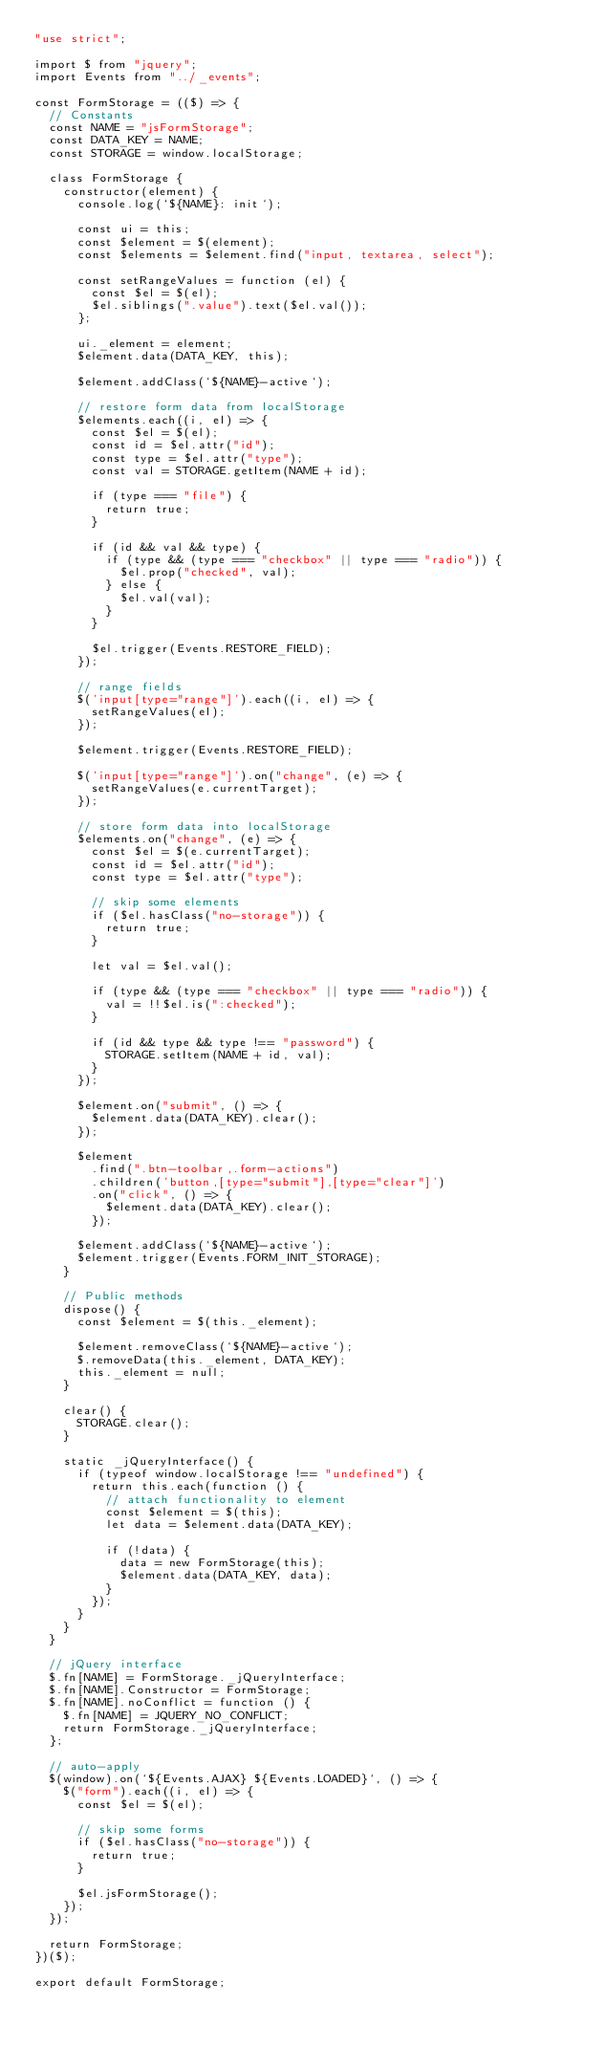Convert code to text. <code><loc_0><loc_0><loc_500><loc_500><_JavaScript_>"use strict";

import $ from "jquery";
import Events from "../_events";

const FormStorage = (($) => {
  // Constants
  const NAME = "jsFormStorage";
  const DATA_KEY = NAME;
  const STORAGE = window.localStorage;

  class FormStorage {
    constructor(element) {
      console.log(`${NAME}: init`);

      const ui = this;
      const $element = $(element);
      const $elements = $element.find("input, textarea, select");

      const setRangeValues = function (el) {
        const $el = $(el);
        $el.siblings(".value").text($el.val());
      };

      ui._element = element;
      $element.data(DATA_KEY, this);

      $element.addClass(`${NAME}-active`);

      // restore form data from localStorage
      $elements.each((i, el) => {
        const $el = $(el);
        const id = $el.attr("id");
        const type = $el.attr("type");
        const val = STORAGE.getItem(NAME + id);

        if (type === "file") {
          return true;
        }

        if (id && val && type) {
          if (type && (type === "checkbox" || type === "radio")) {
            $el.prop("checked", val);
          } else {
            $el.val(val);
          }
        }

        $el.trigger(Events.RESTORE_FIELD);
      });

      // range fields
      $('input[type="range"]').each((i, el) => {
        setRangeValues(el);
      });

      $element.trigger(Events.RESTORE_FIELD);

      $('input[type="range"]').on("change", (e) => {
        setRangeValues(e.currentTarget);
      });

      // store form data into localStorage
      $elements.on("change", (e) => {
        const $el = $(e.currentTarget);
        const id = $el.attr("id");
        const type = $el.attr("type");

        // skip some elements
        if ($el.hasClass("no-storage")) {
          return true;
        }

        let val = $el.val();

        if (type && (type === "checkbox" || type === "radio")) {
          val = !!$el.is(":checked");
        }

        if (id && type && type !== "password") {
          STORAGE.setItem(NAME + id, val);
        }
      });

      $element.on("submit", () => {
        $element.data(DATA_KEY).clear();
      });

      $element
        .find(".btn-toolbar,.form-actions")
        .children('button,[type="submit"],[type="clear"]')
        .on("click", () => {
          $element.data(DATA_KEY).clear();
        });

      $element.addClass(`${NAME}-active`);
      $element.trigger(Events.FORM_INIT_STORAGE);
    }

    // Public methods
    dispose() {
      const $element = $(this._element);

      $element.removeClass(`${NAME}-active`);
      $.removeData(this._element, DATA_KEY);
      this._element = null;
    }

    clear() {
      STORAGE.clear();
    }

    static _jQueryInterface() {
      if (typeof window.localStorage !== "undefined") {
        return this.each(function () {
          // attach functionality to element
          const $element = $(this);
          let data = $element.data(DATA_KEY);

          if (!data) {
            data = new FormStorage(this);
            $element.data(DATA_KEY, data);
          }
        });
      }
    }
  }

  // jQuery interface
  $.fn[NAME] = FormStorage._jQueryInterface;
  $.fn[NAME].Constructor = FormStorage;
  $.fn[NAME].noConflict = function () {
    $.fn[NAME] = JQUERY_NO_CONFLICT;
    return FormStorage._jQueryInterface;
  };

  // auto-apply
  $(window).on(`${Events.AJAX} ${Events.LOADED}`, () => {
    $("form").each((i, el) => {
      const $el = $(el);

      // skip some forms
      if ($el.hasClass("no-storage")) {
        return true;
      }

      $el.jsFormStorage();
    });
  });

  return FormStorage;
})($);

export default FormStorage;
</code> 